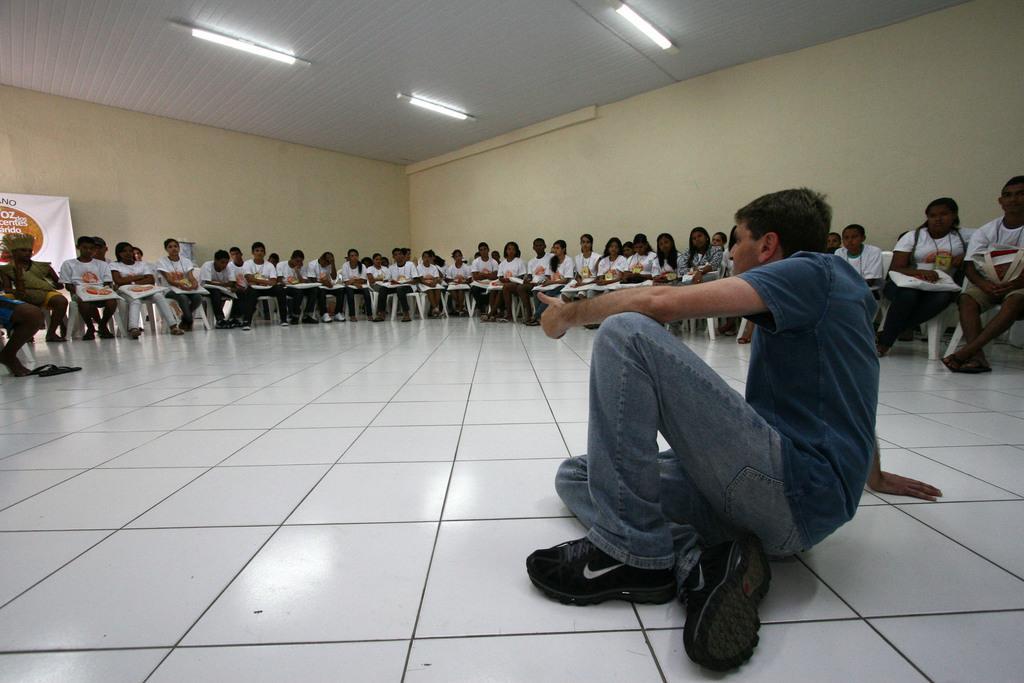In one or two sentences, can you explain what this image depicts? This image is taken indoors. At the bottom of the image there is a floor. In the background there are two walls and there is a banner with a text on it. At the top of the image there is a roof with a few lights. In the middle of the image many people are sitting on chairs and they are holding a few objects in their hands. On the right side of the image a man is sitting on the floor. 